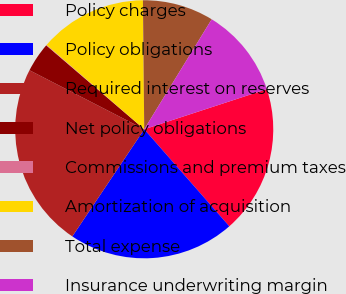Convert chart. <chart><loc_0><loc_0><loc_500><loc_500><pie_chart><fcel>Policy charges<fcel>Policy obligations<fcel>Required interest on reserves<fcel>Net policy obligations<fcel>Commissions and premium taxes<fcel>Amortization of acquisition<fcel>Total expense<fcel>Insurance underwriting margin<nl><fcel>18.58%<fcel>20.87%<fcel>23.16%<fcel>3.71%<fcel>0.07%<fcel>13.5%<fcel>8.92%<fcel>11.21%<nl></chart> 